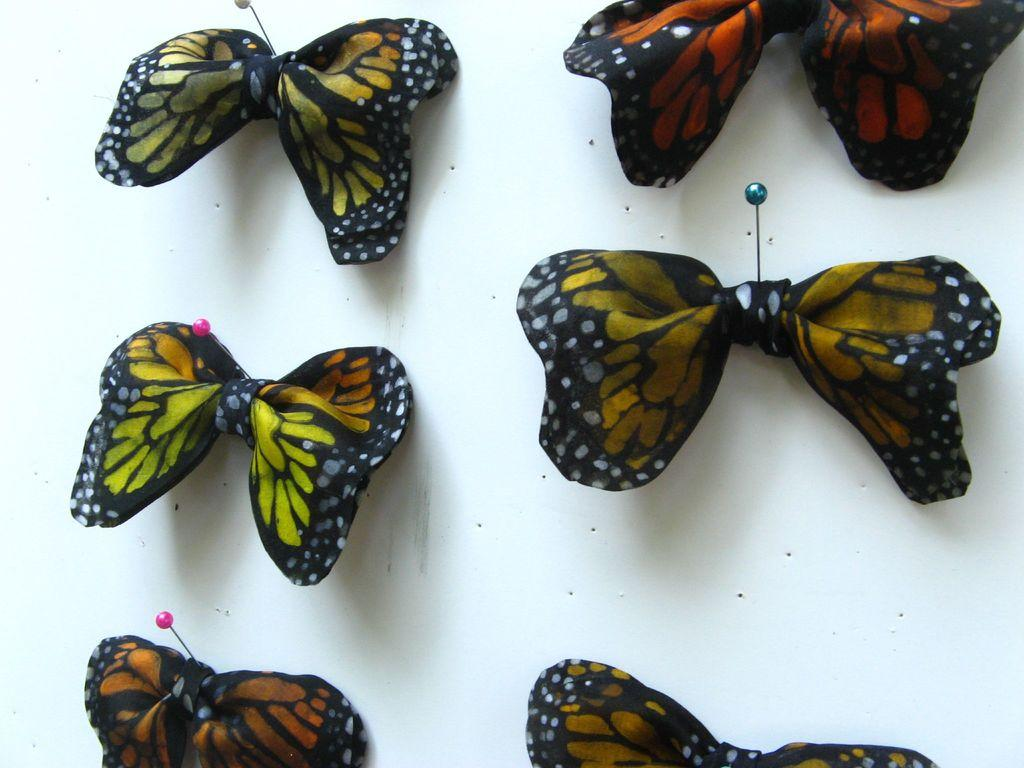What type of animals are present in the image? There are butterflies in the image. What unique feature do the butterflies have? The butterflies have ribbons. What is the primary object in the image? There is a white platform in the image. How many nuts are on the white platform in the image? There are no nuts present in the image; it features butterflies with ribbons on a white platform. 